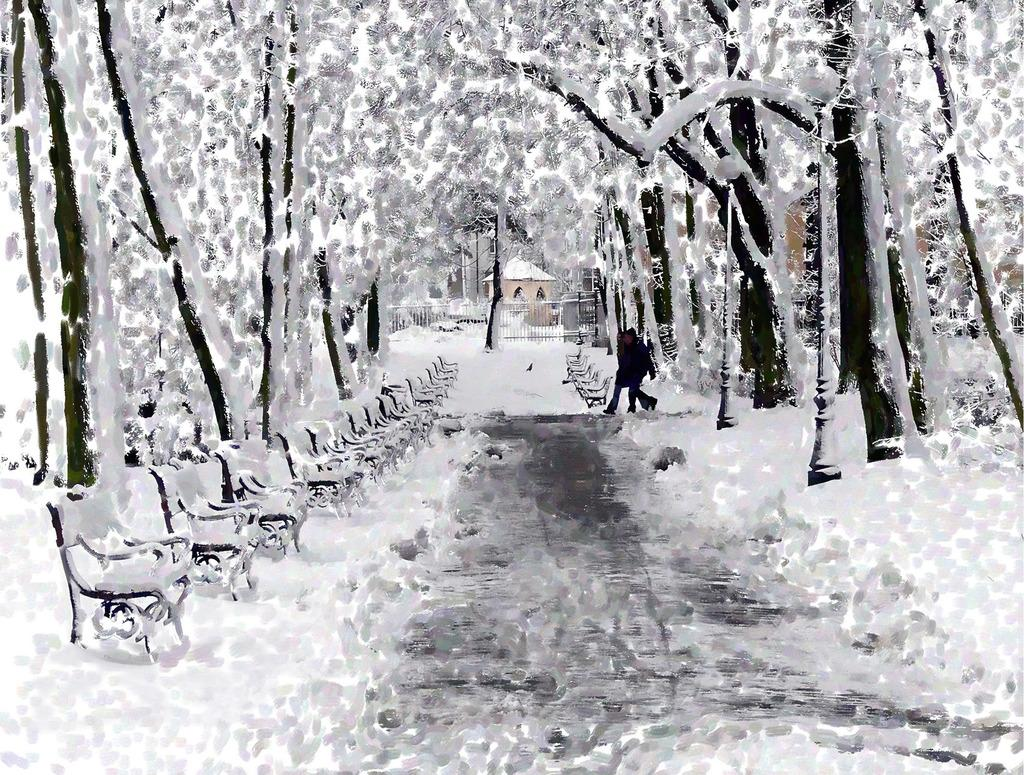What type of picture is in the image? The image contains an edited picture. What natural elements can be seen in the image? There are trees in the image. What type of seating is available in the image? There are benches in the image. What type of pathway is present in the image? There is a road in the image. What type of structure is visible in the image? There is a building in the image. Are there any people in the image? Yes, there are persons in the image. What type of barrier is present in the image? There is an iron grill in the image. What type of tax is being discussed by the persons in the image? There is no indication in the image that the persons are discussing any type of tax. 